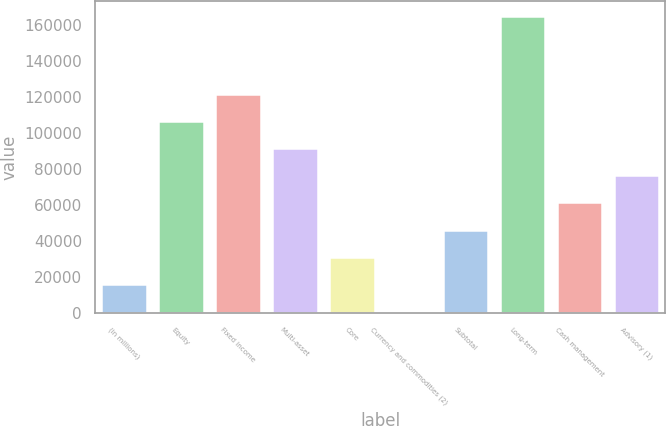Convert chart. <chart><loc_0><loc_0><loc_500><loc_500><bar_chart><fcel>(in millions)<fcel>Equity<fcel>Fixed income<fcel>Multi-asset<fcel>Core<fcel>Currency and commodities (2)<fcel>Subtotal<fcel>Long-term<fcel>Cash management<fcel>Advisory (1)<nl><fcel>16141.9<fcel>106723<fcel>121820<fcel>91626.4<fcel>31238.8<fcel>1045<fcel>46335.7<fcel>164992<fcel>61432.6<fcel>76529.5<nl></chart> 